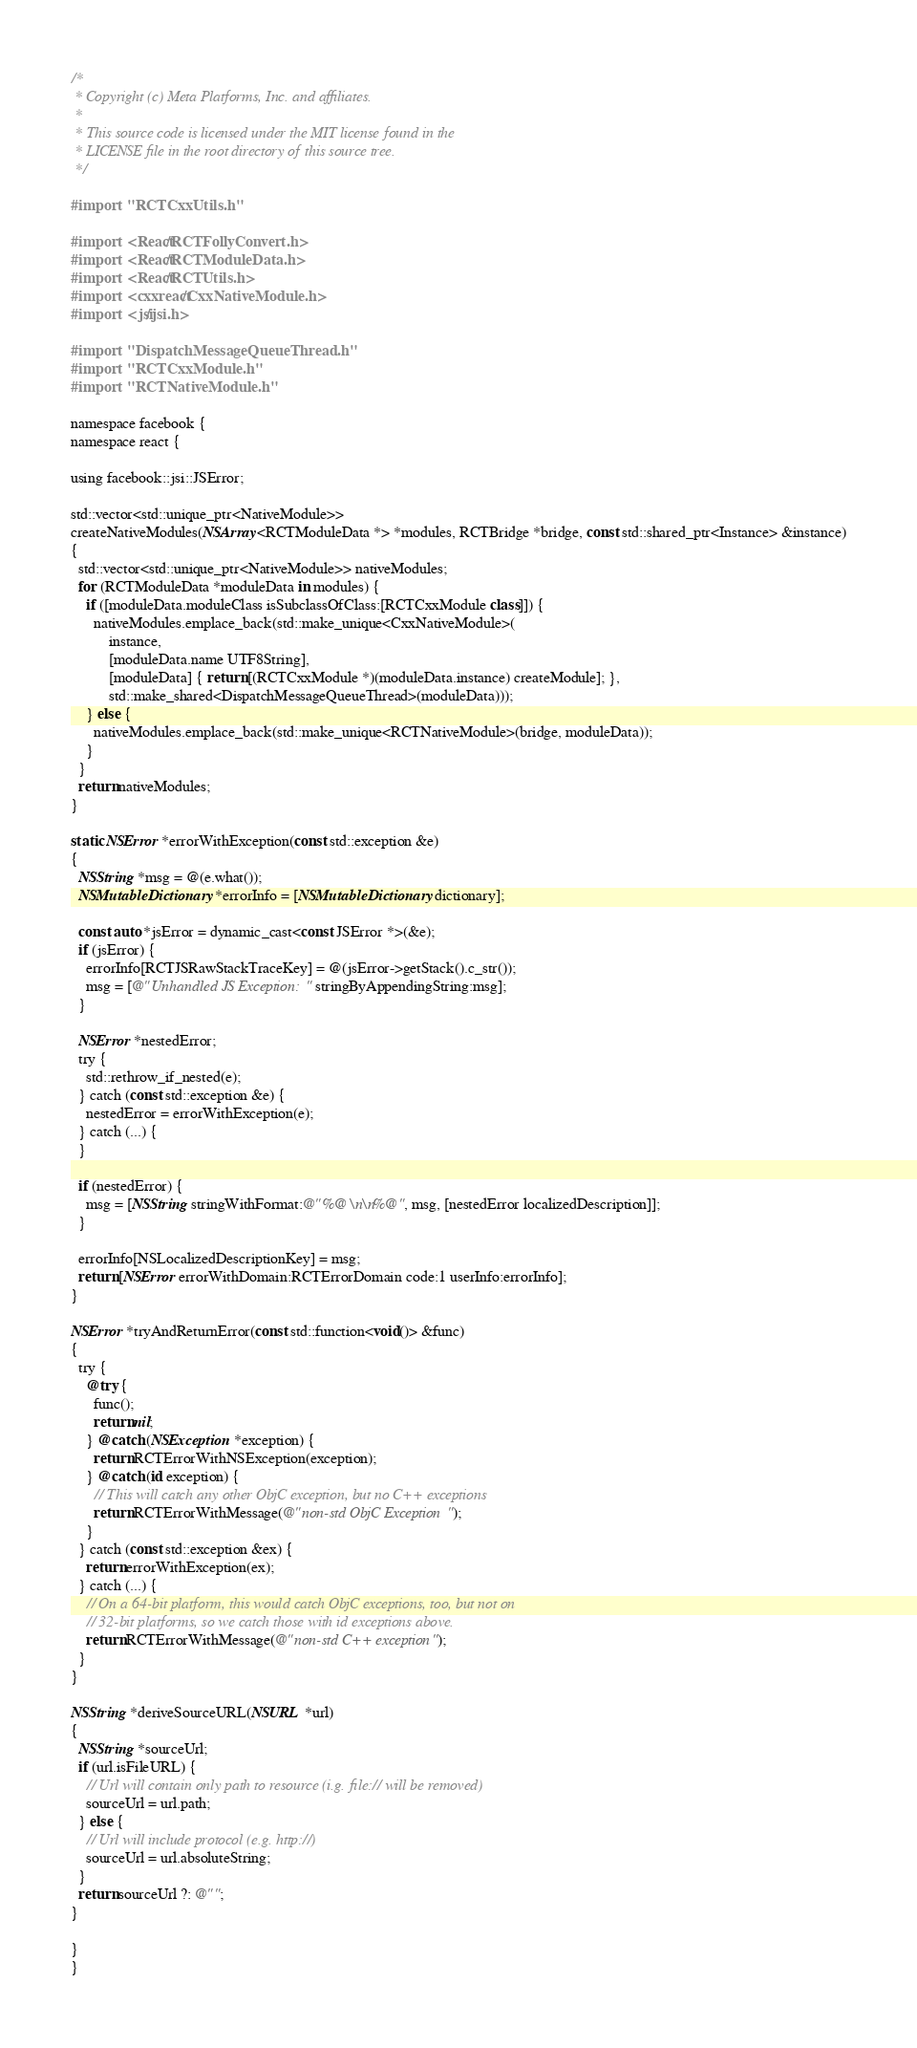Convert code to text. <code><loc_0><loc_0><loc_500><loc_500><_ObjectiveC_>/*
 * Copyright (c) Meta Platforms, Inc. and affiliates.
 *
 * This source code is licensed under the MIT license found in the
 * LICENSE file in the root directory of this source tree.
 */

#import "RCTCxxUtils.h"

#import <React/RCTFollyConvert.h>
#import <React/RCTModuleData.h>
#import <React/RCTUtils.h>
#import <cxxreact/CxxNativeModule.h>
#import <jsi/jsi.h>

#import "DispatchMessageQueueThread.h"
#import "RCTCxxModule.h"
#import "RCTNativeModule.h"

namespace facebook {
namespace react {

using facebook::jsi::JSError;

std::vector<std::unique_ptr<NativeModule>>
createNativeModules(NSArray<RCTModuleData *> *modules, RCTBridge *bridge, const std::shared_ptr<Instance> &instance)
{
  std::vector<std::unique_ptr<NativeModule>> nativeModules;
  for (RCTModuleData *moduleData in modules) {
    if ([moduleData.moduleClass isSubclassOfClass:[RCTCxxModule class]]) {
      nativeModules.emplace_back(std::make_unique<CxxNativeModule>(
          instance,
          [moduleData.name UTF8String],
          [moduleData] { return [(RCTCxxModule *)(moduleData.instance) createModule]; },
          std::make_shared<DispatchMessageQueueThread>(moduleData)));
    } else {
      nativeModules.emplace_back(std::make_unique<RCTNativeModule>(bridge, moduleData));
    }
  }
  return nativeModules;
}

static NSError *errorWithException(const std::exception &e)
{
  NSString *msg = @(e.what());
  NSMutableDictionary *errorInfo = [NSMutableDictionary dictionary];

  const auto *jsError = dynamic_cast<const JSError *>(&e);
  if (jsError) {
    errorInfo[RCTJSRawStackTraceKey] = @(jsError->getStack().c_str());
    msg = [@"Unhandled JS Exception: " stringByAppendingString:msg];
  }

  NSError *nestedError;
  try {
    std::rethrow_if_nested(e);
  } catch (const std::exception &e) {
    nestedError = errorWithException(e);
  } catch (...) {
  }

  if (nestedError) {
    msg = [NSString stringWithFormat:@"%@\n\n%@", msg, [nestedError localizedDescription]];
  }

  errorInfo[NSLocalizedDescriptionKey] = msg;
  return [NSError errorWithDomain:RCTErrorDomain code:1 userInfo:errorInfo];
}

NSError *tryAndReturnError(const std::function<void()> &func)
{
  try {
    @try {
      func();
      return nil;
    } @catch (NSException *exception) {
      return RCTErrorWithNSException(exception);
    } @catch (id exception) {
      // This will catch any other ObjC exception, but no C++ exceptions
      return RCTErrorWithMessage(@"non-std ObjC Exception");
    }
  } catch (const std::exception &ex) {
    return errorWithException(ex);
  } catch (...) {
    // On a 64-bit platform, this would catch ObjC exceptions, too, but not on
    // 32-bit platforms, so we catch those with id exceptions above.
    return RCTErrorWithMessage(@"non-std C++ exception");
  }
}

NSString *deriveSourceURL(NSURL *url)
{
  NSString *sourceUrl;
  if (url.isFileURL) {
    // Url will contain only path to resource (i.g. file:// will be removed)
    sourceUrl = url.path;
  } else {
    // Url will include protocol (e.g. http://)
    sourceUrl = url.absoluteString;
  }
  return sourceUrl ?: @"";
}

}
}
</code> 